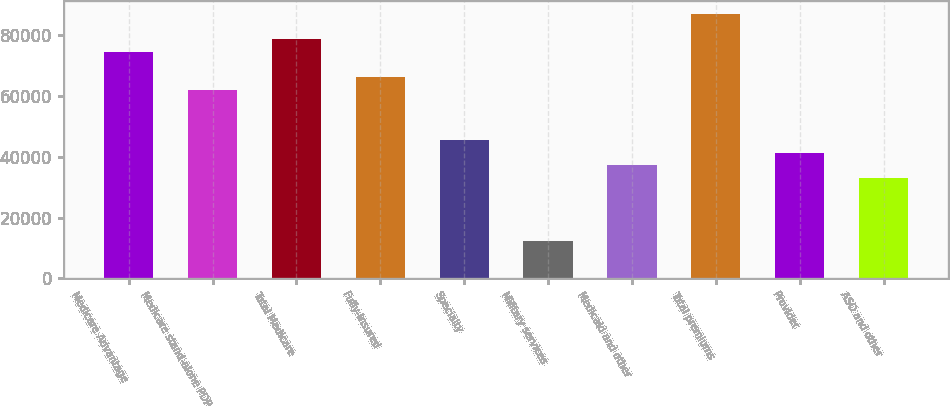Convert chart to OTSL. <chart><loc_0><loc_0><loc_500><loc_500><bar_chart><fcel>Medicare Advantage<fcel>Medicare stand-alone PDP<fcel>Total Medicare<fcel>Fully-insured<fcel>Specialty<fcel>Military services<fcel>Medicaid and other<fcel>Total premiums<fcel>Provider<fcel>ASO and other<nl><fcel>74361.7<fcel>61968.4<fcel>78492.8<fcel>66099.5<fcel>45444.1<fcel>12395.4<fcel>37181.9<fcel>86755<fcel>41313<fcel>33050.8<nl></chart> 